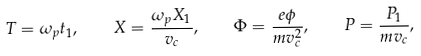Convert formula to latex. <formula><loc_0><loc_0><loc_500><loc_500>T = \omega _ { p } t _ { 1 } , \quad X = { \frac { \omega _ { p } X _ { 1 } } { v _ { c } } } , \quad \Phi = { \frac { e \phi } { m v _ { c } ^ { 2 } } } , \quad P = { \frac { P _ { 1 } } { m v _ { c } } } ,</formula> 